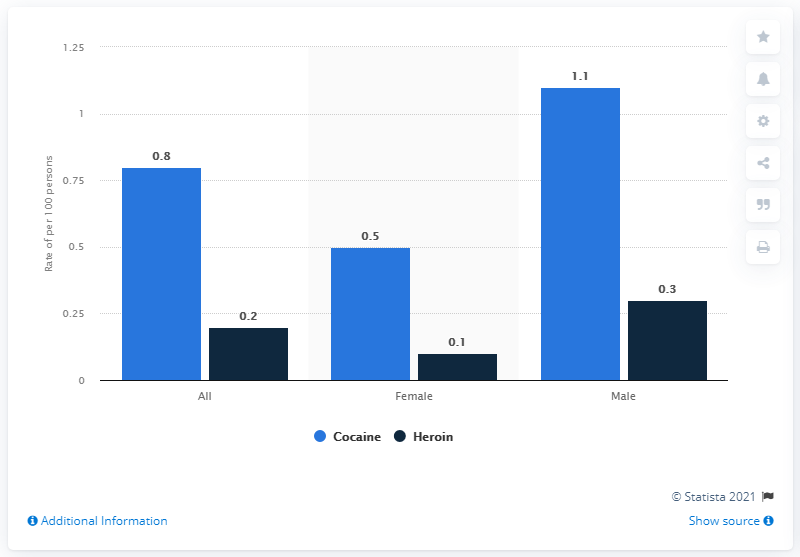Highlight a few significant elements in this photo. Females consume 0.1% of Heroin. According to data from 2017, the rate of cocaine use in the United States was 0.8%. It is the belief that males have the highest value. In the year 2017, self-reported illicit heroin use in the United States was 0.2%. 